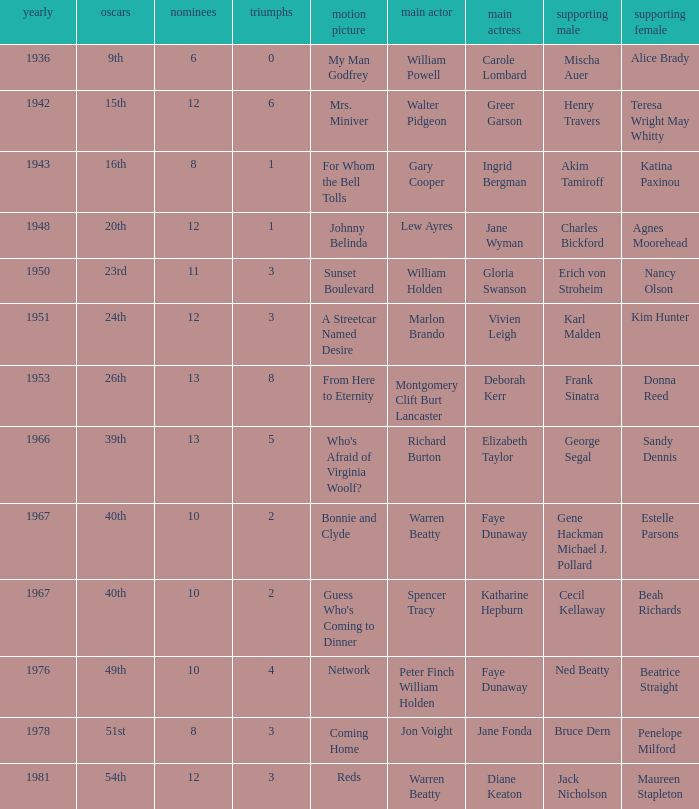Who was the supporting actress in "For Whom the Bell Tolls"? Katina Paxinou. 